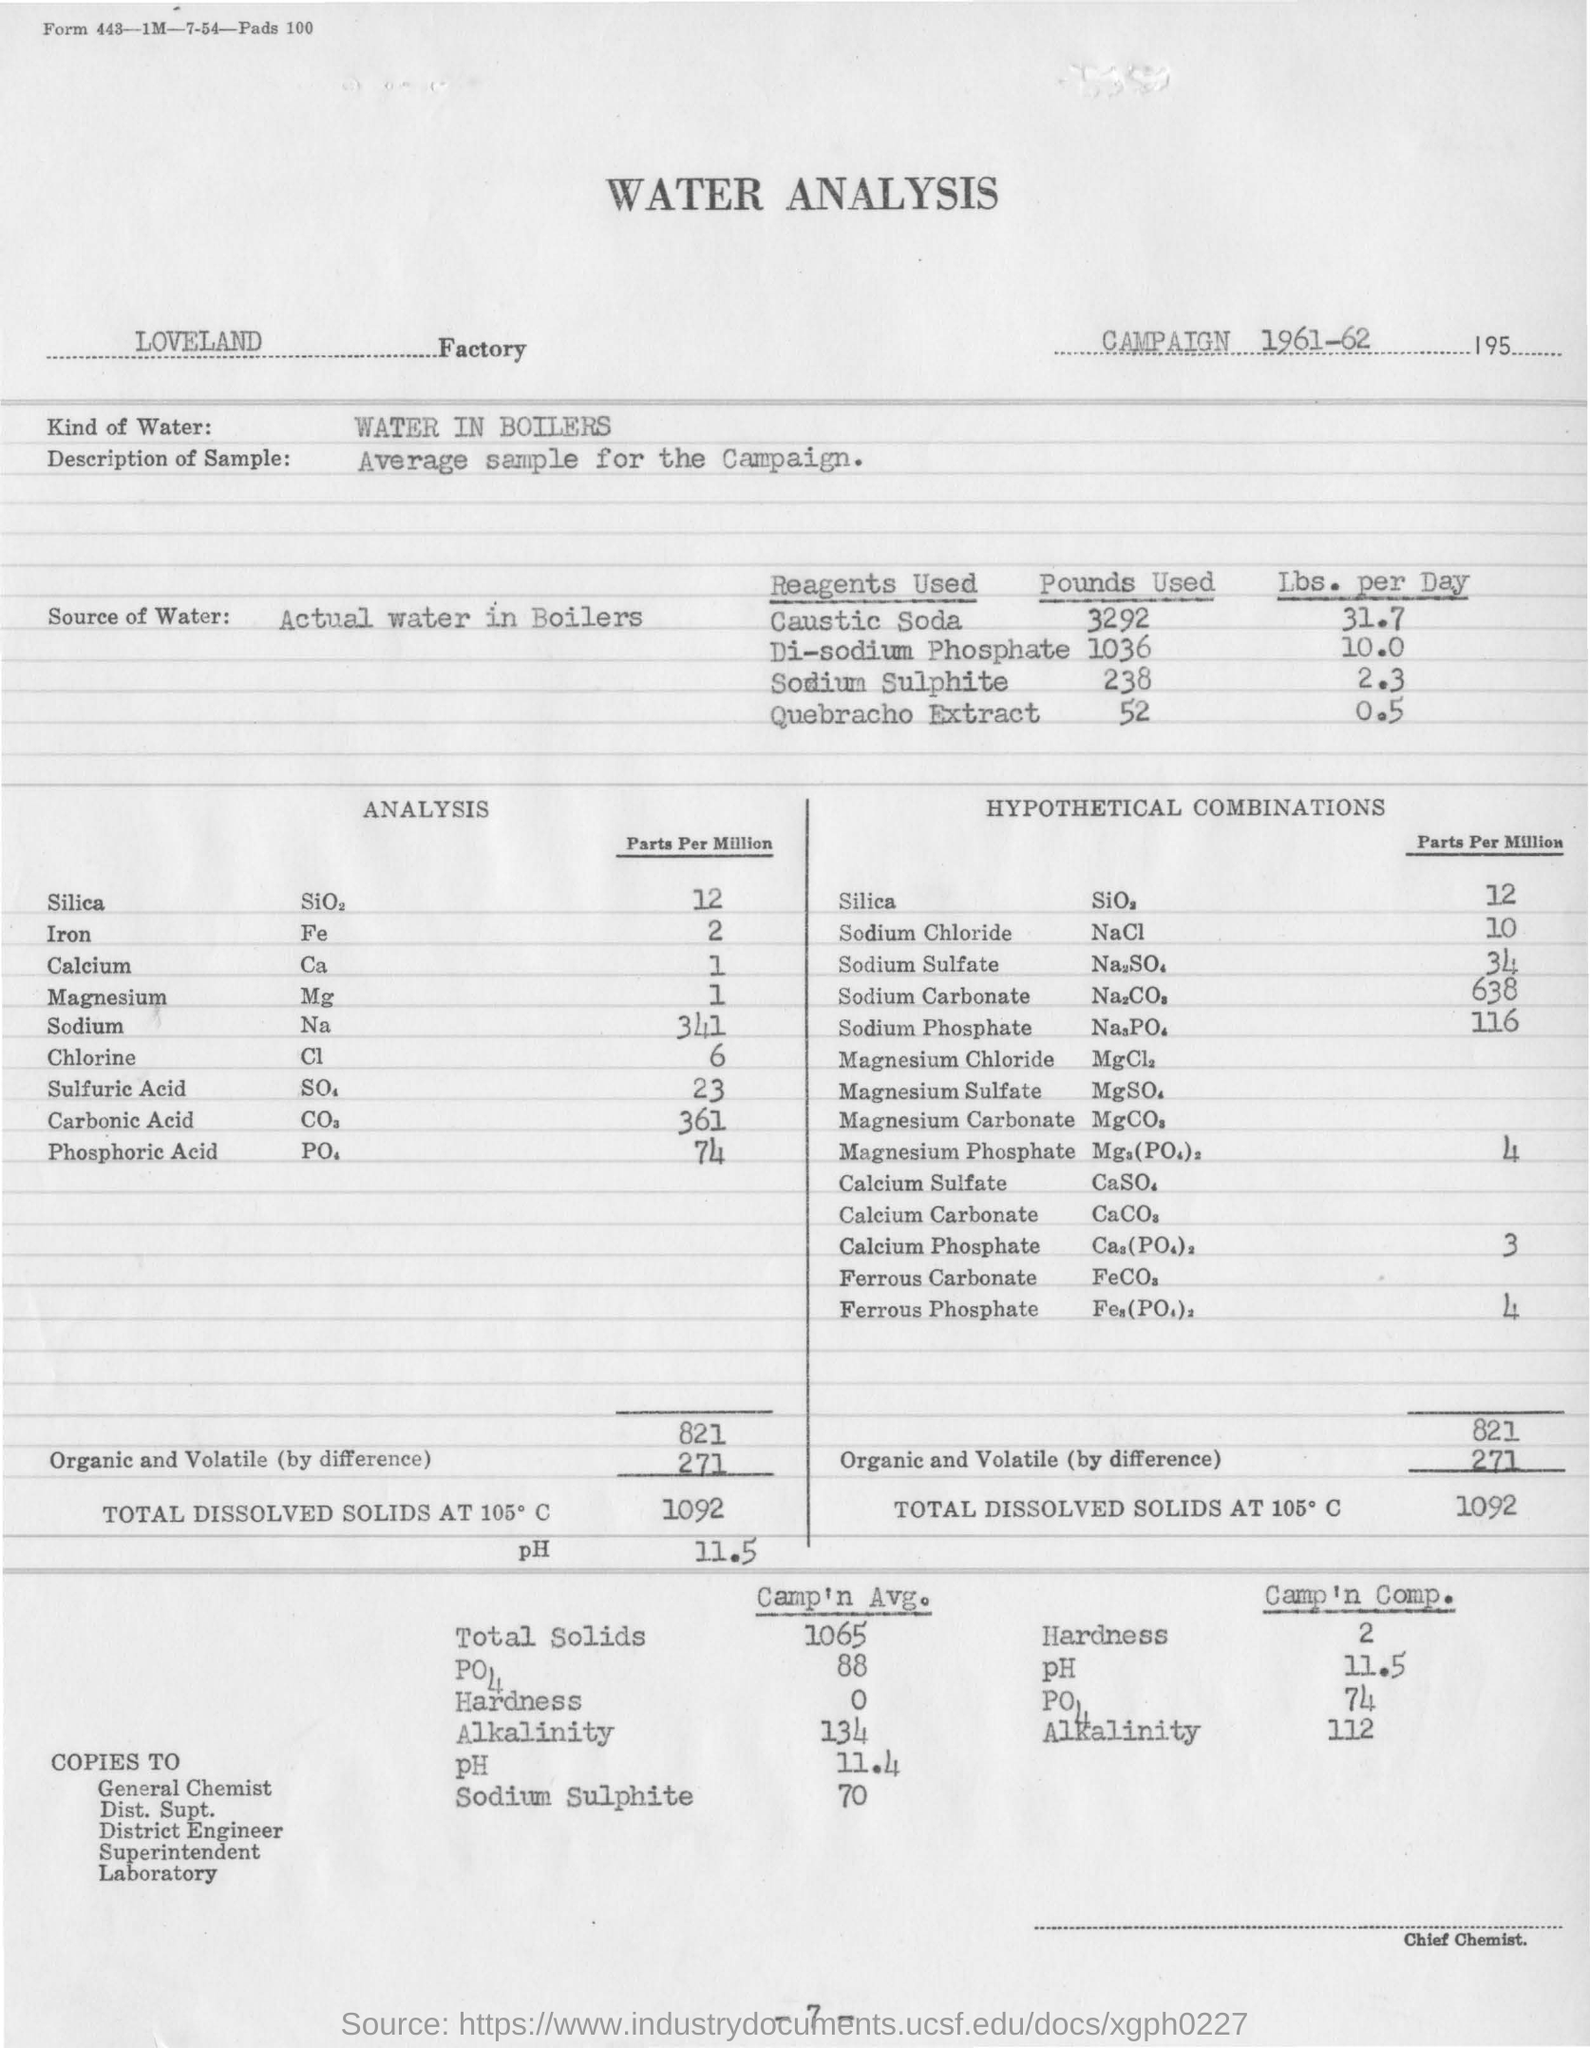Mention a couple of crucial points in this snapshot. The source of water for the analysis is actual water in the boilers. The analysis for Factory is conducted in Loveland. The type of water used for the analysis is water from boilers. In the analysis, the concentration of chlorine was found to be 6 parts per million. The campaign was held in the year 1961-62. 